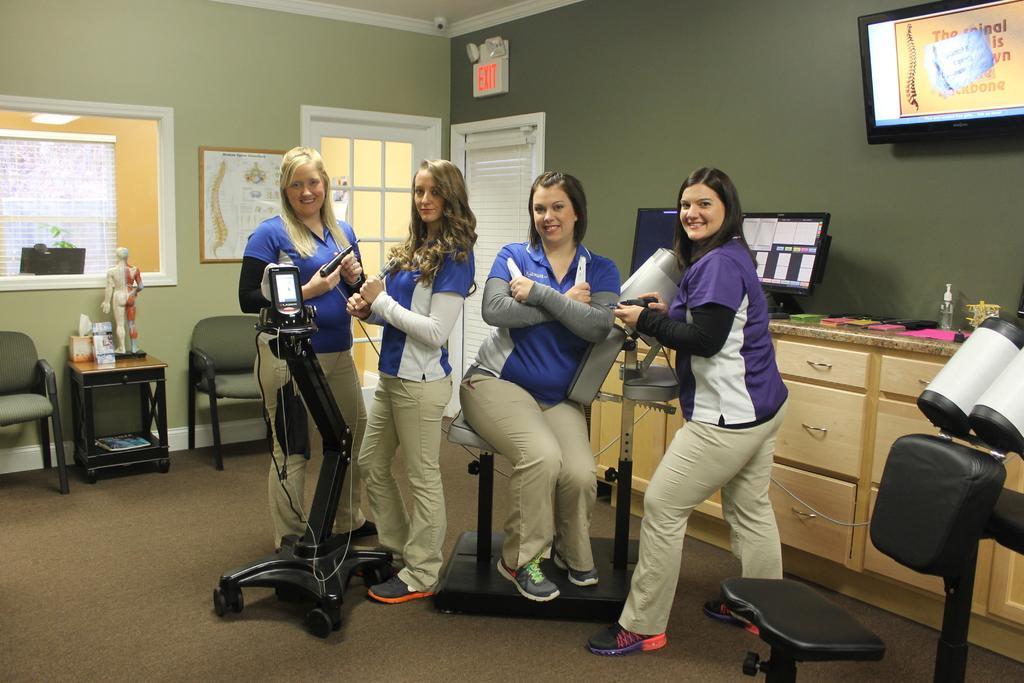Please provide a concise description of this image. This is the picture in a row where we have four ladies wearing blue shirts and cream color pants and in the room we have some chairs and a stool on which there are some things and a window, a exit board and a system on the desk and some things on the desk and a screen to the right wall. 